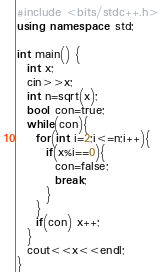<code> <loc_0><loc_0><loc_500><loc_500><_C++_>#include <bits/stdc++.h>
using namespace std;

int main() {
  int x;
  cin>>x;
  int n=sqrt(x);
  bool con=true;
  while(con){
    for(int i=2;i<=n;i++){
      if(x%i==0){
        con=false;
        break;
      }
    }
    if(con) x++;
  }
  cout<<x<<endl;
}</code> 